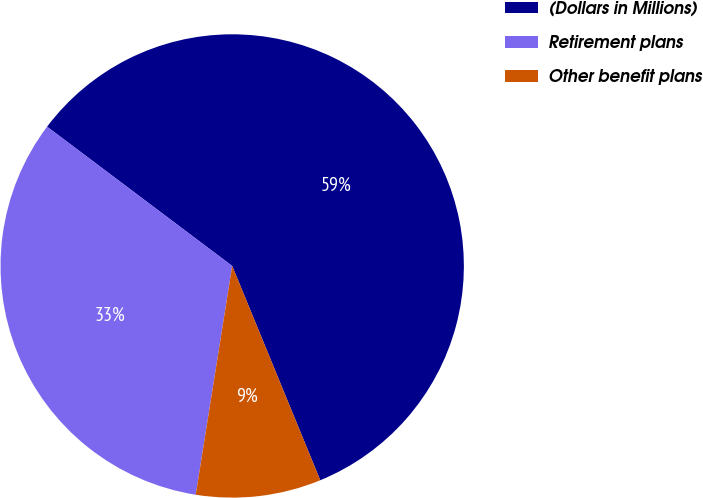Convert chart. <chart><loc_0><loc_0><loc_500><loc_500><pie_chart><fcel>(Dollars in Millions)<fcel>Retirement plans<fcel>Other benefit plans<nl><fcel>58.53%<fcel>32.75%<fcel>8.72%<nl></chart> 